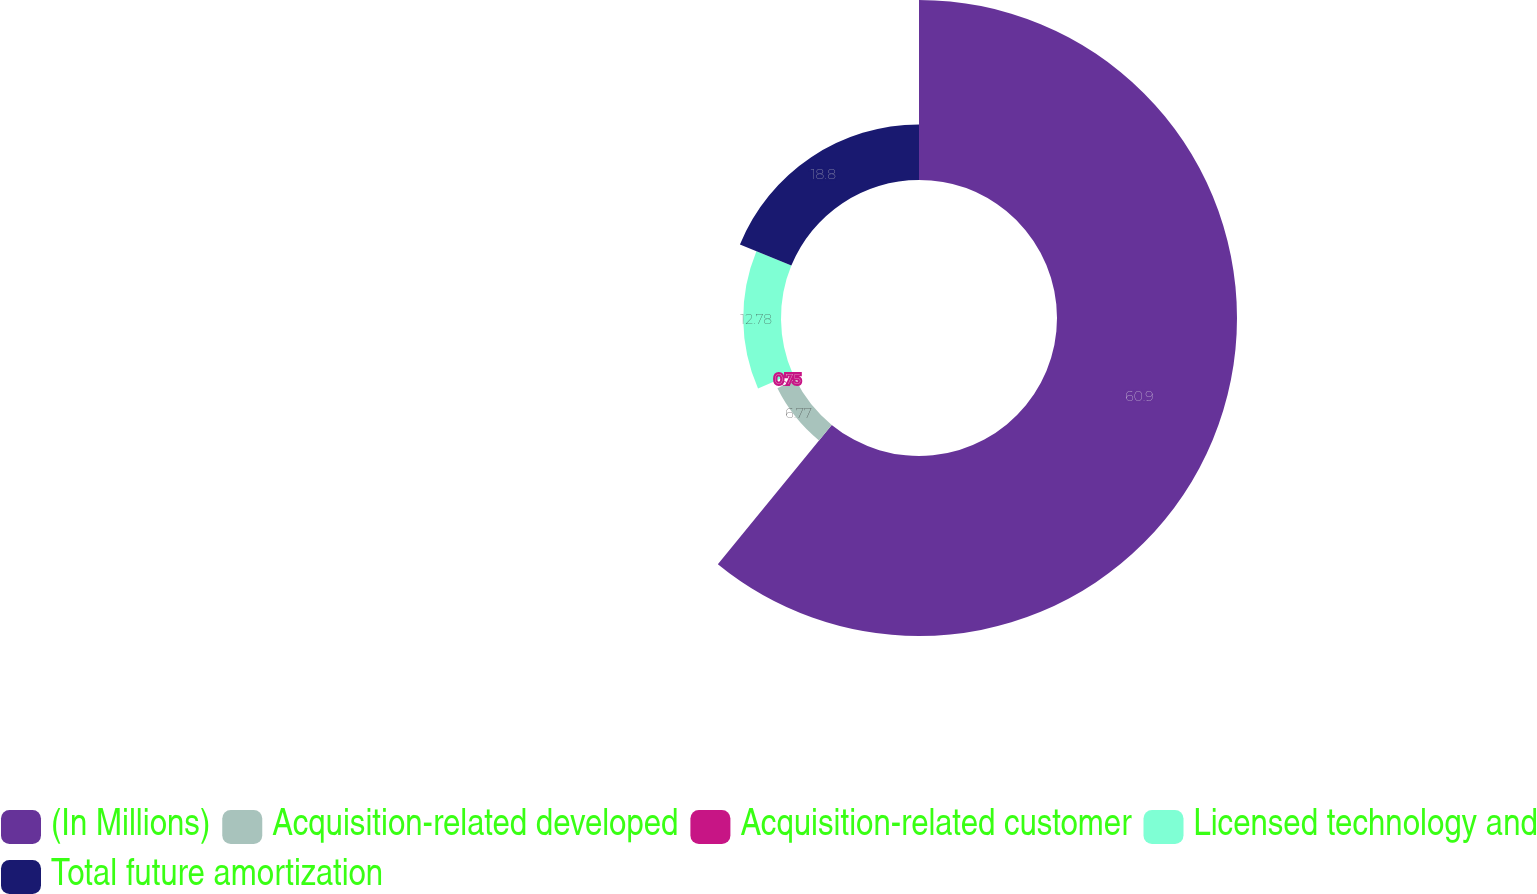Convert chart. <chart><loc_0><loc_0><loc_500><loc_500><pie_chart><fcel>(In Millions)<fcel>Acquisition-related developed<fcel>Acquisition-related customer<fcel>Licensed technology and<fcel>Total future amortization<nl><fcel>60.9%<fcel>6.77%<fcel>0.75%<fcel>12.78%<fcel>18.8%<nl></chart> 